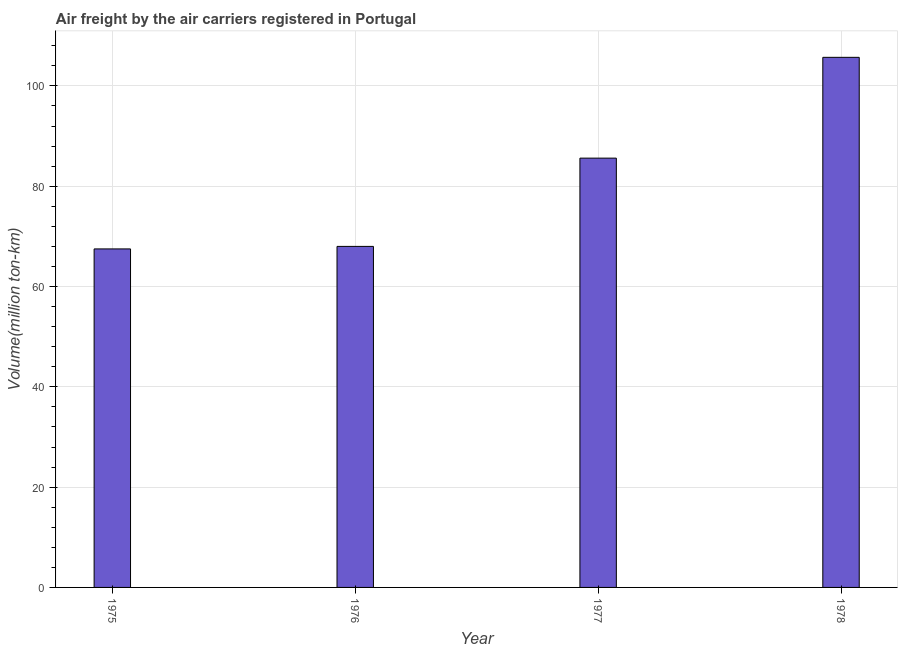Does the graph contain any zero values?
Your response must be concise. No. What is the title of the graph?
Provide a short and direct response. Air freight by the air carriers registered in Portugal. What is the label or title of the X-axis?
Keep it short and to the point. Year. What is the label or title of the Y-axis?
Give a very brief answer. Volume(million ton-km). What is the air freight in 1977?
Offer a very short reply. 85.6. Across all years, what is the maximum air freight?
Provide a succinct answer. 105.7. Across all years, what is the minimum air freight?
Your answer should be very brief. 67.5. In which year was the air freight maximum?
Your response must be concise. 1978. In which year was the air freight minimum?
Your answer should be compact. 1975. What is the sum of the air freight?
Make the answer very short. 326.8. What is the difference between the air freight in 1977 and 1978?
Your answer should be very brief. -20.1. What is the average air freight per year?
Keep it short and to the point. 81.7. What is the median air freight?
Provide a succinct answer. 76.8. In how many years, is the air freight greater than 68 million ton-km?
Provide a succinct answer. 2. Do a majority of the years between 1976 and 1978 (inclusive) have air freight greater than 8 million ton-km?
Keep it short and to the point. Yes. What is the ratio of the air freight in 1975 to that in 1976?
Make the answer very short. 0.99. What is the difference between the highest and the second highest air freight?
Your response must be concise. 20.1. What is the difference between the highest and the lowest air freight?
Your answer should be compact. 38.2. How many years are there in the graph?
Your answer should be very brief. 4. What is the difference between two consecutive major ticks on the Y-axis?
Provide a succinct answer. 20. What is the Volume(million ton-km) in 1975?
Offer a very short reply. 67.5. What is the Volume(million ton-km) of 1977?
Make the answer very short. 85.6. What is the Volume(million ton-km) in 1978?
Your answer should be very brief. 105.7. What is the difference between the Volume(million ton-km) in 1975 and 1977?
Your response must be concise. -18.1. What is the difference between the Volume(million ton-km) in 1975 and 1978?
Your answer should be very brief. -38.2. What is the difference between the Volume(million ton-km) in 1976 and 1977?
Your answer should be very brief. -17.6. What is the difference between the Volume(million ton-km) in 1976 and 1978?
Offer a terse response. -37.7. What is the difference between the Volume(million ton-km) in 1977 and 1978?
Ensure brevity in your answer.  -20.1. What is the ratio of the Volume(million ton-km) in 1975 to that in 1976?
Your answer should be very brief. 0.99. What is the ratio of the Volume(million ton-km) in 1975 to that in 1977?
Your response must be concise. 0.79. What is the ratio of the Volume(million ton-km) in 1975 to that in 1978?
Offer a very short reply. 0.64. What is the ratio of the Volume(million ton-km) in 1976 to that in 1977?
Provide a succinct answer. 0.79. What is the ratio of the Volume(million ton-km) in 1976 to that in 1978?
Make the answer very short. 0.64. What is the ratio of the Volume(million ton-km) in 1977 to that in 1978?
Your answer should be very brief. 0.81. 